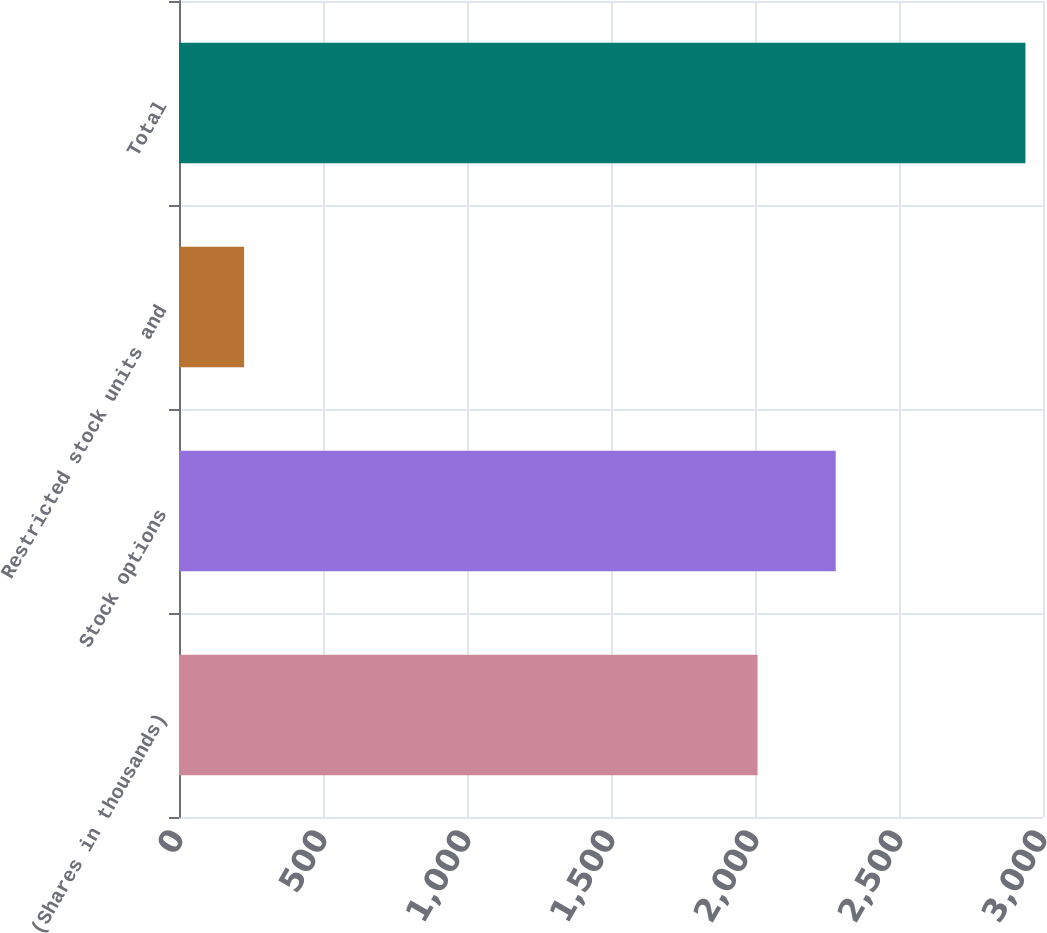Convert chart to OTSL. <chart><loc_0><loc_0><loc_500><loc_500><bar_chart><fcel>(Shares in thousands)<fcel>Stock options<fcel>Restricted stock units and<fcel>Total<nl><fcel>2009<fcel>2280.3<fcel>226<fcel>2939<nl></chart> 